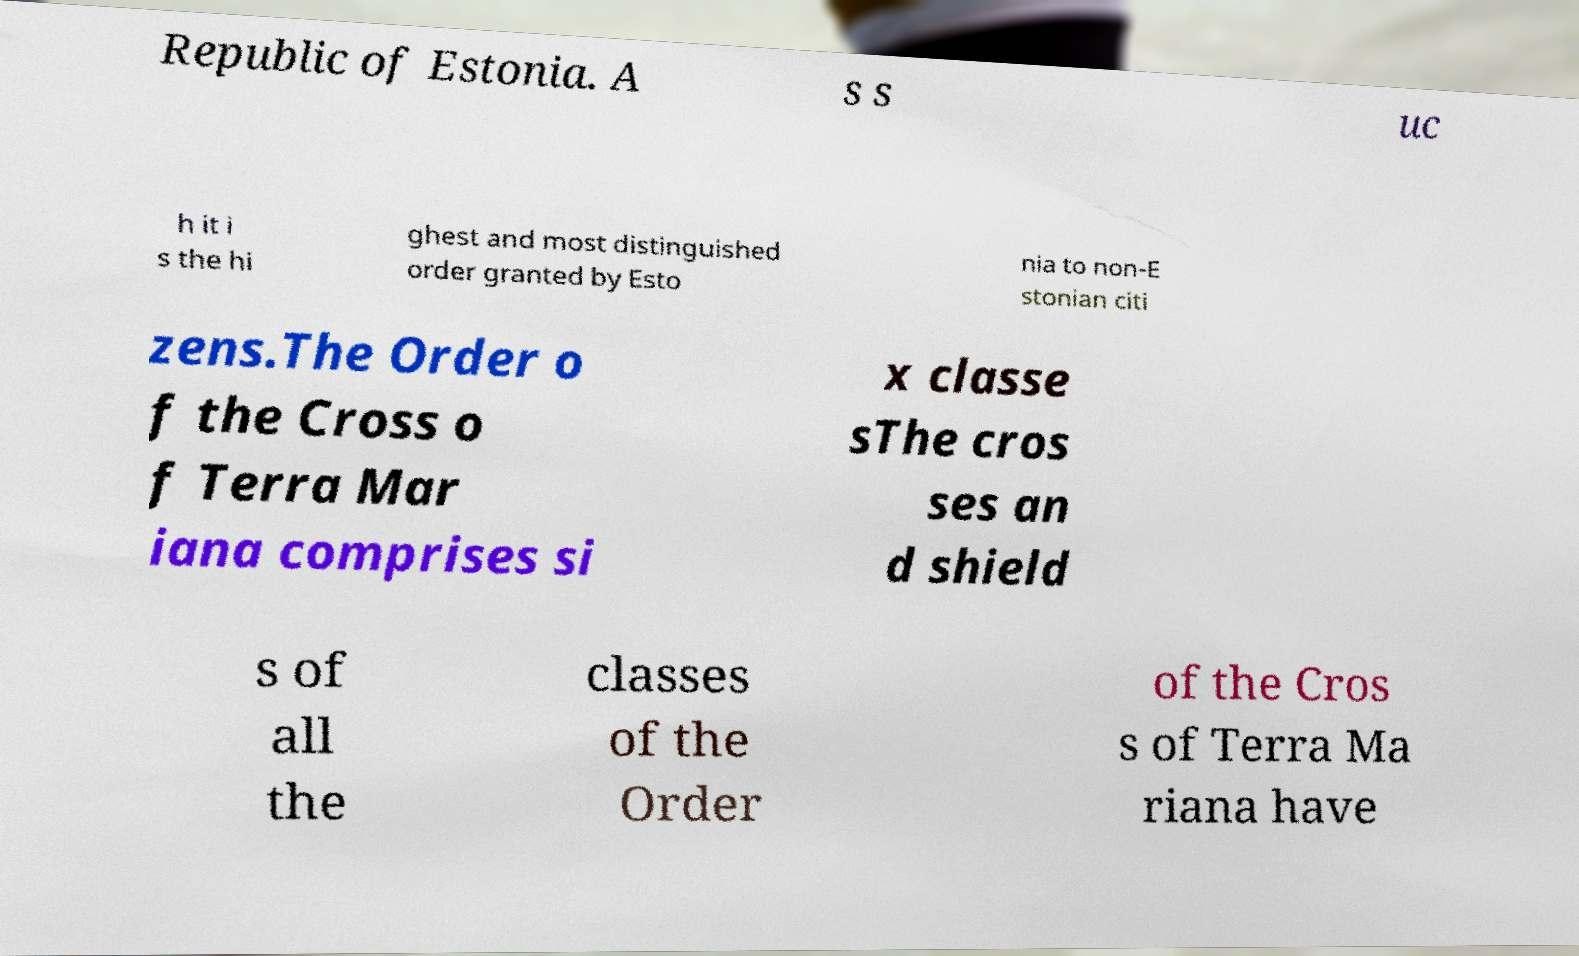I need the written content from this picture converted into text. Can you do that? Republic of Estonia. A s s uc h it i s the hi ghest and most distinguished order granted by Esto nia to non-E stonian citi zens.The Order o f the Cross o f Terra Mar iana comprises si x classe sThe cros ses an d shield s of all the classes of the Order of the Cros s of Terra Ma riana have 